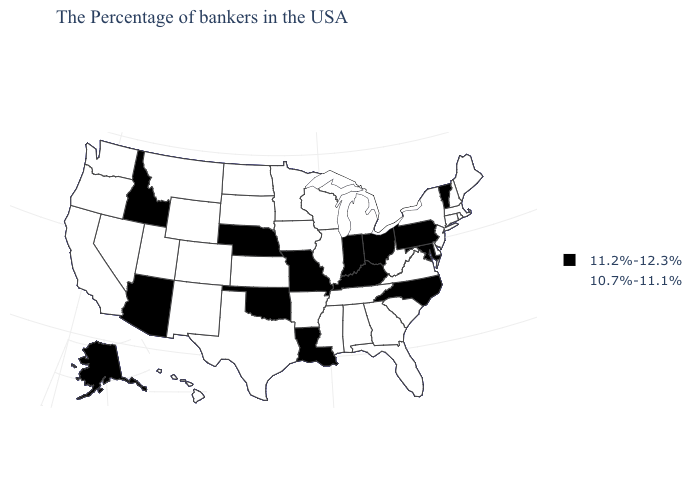What is the value of Alaska?
Give a very brief answer. 11.2%-12.3%. Among the states that border Maine , which have the lowest value?
Keep it brief. New Hampshire. Name the states that have a value in the range 10.7%-11.1%?
Be succinct. Maine, Massachusetts, Rhode Island, New Hampshire, Connecticut, New York, New Jersey, Delaware, Virginia, South Carolina, West Virginia, Florida, Georgia, Michigan, Alabama, Tennessee, Wisconsin, Illinois, Mississippi, Arkansas, Minnesota, Iowa, Kansas, Texas, South Dakota, North Dakota, Wyoming, Colorado, New Mexico, Utah, Montana, Nevada, California, Washington, Oregon, Hawaii. Name the states that have a value in the range 10.7%-11.1%?
Quick response, please. Maine, Massachusetts, Rhode Island, New Hampshire, Connecticut, New York, New Jersey, Delaware, Virginia, South Carolina, West Virginia, Florida, Georgia, Michigan, Alabama, Tennessee, Wisconsin, Illinois, Mississippi, Arkansas, Minnesota, Iowa, Kansas, Texas, South Dakota, North Dakota, Wyoming, Colorado, New Mexico, Utah, Montana, Nevada, California, Washington, Oregon, Hawaii. What is the value of Arizona?
Be succinct. 11.2%-12.3%. Does Idaho have a higher value than Alaska?
Be succinct. No. How many symbols are there in the legend?
Answer briefly. 2. Does Ohio have the same value as Wisconsin?
Write a very short answer. No. Name the states that have a value in the range 10.7%-11.1%?
Keep it brief. Maine, Massachusetts, Rhode Island, New Hampshire, Connecticut, New York, New Jersey, Delaware, Virginia, South Carolina, West Virginia, Florida, Georgia, Michigan, Alabama, Tennessee, Wisconsin, Illinois, Mississippi, Arkansas, Minnesota, Iowa, Kansas, Texas, South Dakota, North Dakota, Wyoming, Colorado, New Mexico, Utah, Montana, Nevada, California, Washington, Oregon, Hawaii. Which states have the lowest value in the USA?
Concise answer only. Maine, Massachusetts, Rhode Island, New Hampshire, Connecticut, New York, New Jersey, Delaware, Virginia, South Carolina, West Virginia, Florida, Georgia, Michigan, Alabama, Tennessee, Wisconsin, Illinois, Mississippi, Arkansas, Minnesota, Iowa, Kansas, Texas, South Dakota, North Dakota, Wyoming, Colorado, New Mexico, Utah, Montana, Nevada, California, Washington, Oregon, Hawaii. What is the lowest value in the USA?
Be succinct. 10.7%-11.1%. Name the states that have a value in the range 10.7%-11.1%?
Quick response, please. Maine, Massachusetts, Rhode Island, New Hampshire, Connecticut, New York, New Jersey, Delaware, Virginia, South Carolina, West Virginia, Florida, Georgia, Michigan, Alabama, Tennessee, Wisconsin, Illinois, Mississippi, Arkansas, Minnesota, Iowa, Kansas, Texas, South Dakota, North Dakota, Wyoming, Colorado, New Mexico, Utah, Montana, Nevada, California, Washington, Oregon, Hawaii. Name the states that have a value in the range 10.7%-11.1%?
Be succinct. Maine, Massachusetts, Rhode Island, New Hampshire, Connecticut, New York, New Jersey, Delaware, Virginia, South Carolina, West Virginia, Florida, Georgia, Michigan, Alabama, Tennessee, Wisconsin, Illinois, Mississippi, Arkansas, Minnesota, Iowa, Kansas, Texas, South Dakota, North Dakota, Wyoming, Colorado, New Mexico, Utah, Montana, Nevada, California, Washington, Oregon, Hawaii. Name the states that have a value in the range 10.7%-11.1%?
Short answer required. Maine, Massachusetts, Rhode Island, New Hampshire, Connecticut, New York, New Jersey, Delaware, Virginia, South Carolina, West Virginia, Florida, Georgia, Michigan, Alabama, Tennessee, Wisconsin, Illinois, Mississippi, Arkansas, Minnesota, Iowa, Kansas, Texas, South Dakota, North Dakota, Wyoming, Colorado, New Mexico, Utah, Montana, Nevada, California, Washington, Oregon, Hawaii. 